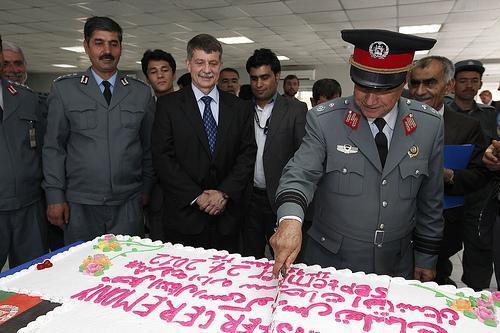How many people are cutting the cake?
Give a very brief answer. 1. How many officers are in the photo?
Give a very brief answer. 3. How many men are wearing a gray uniform?
Give a very brief answer. 4. 